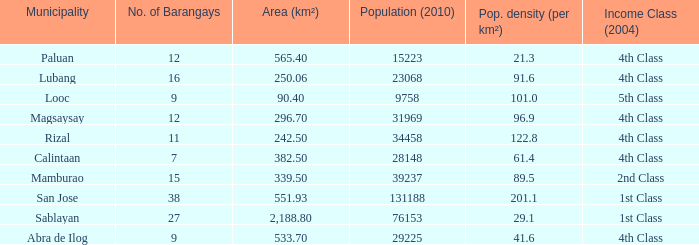What is the population density for the city of lubang? 1.0. 